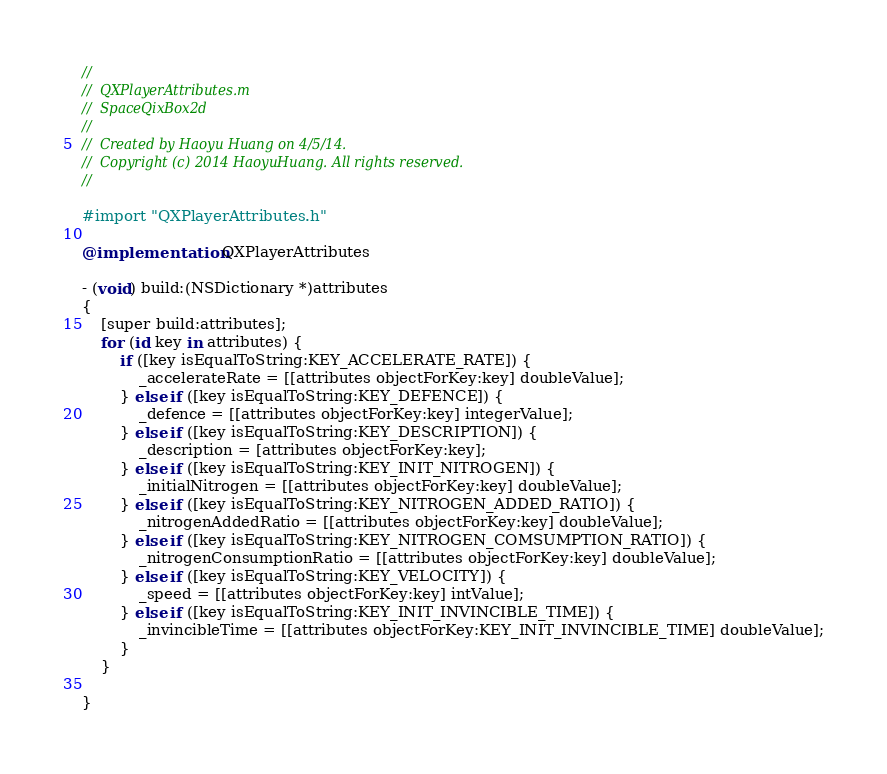Convert code to text. <code><loc_0><loc_0><loc_500><loc_500><_ObjectiveC_>//
//  QXPlayerAttributes.m
//  SpaceQixBox2d
//
//  Created by Haoyu Huang on 4/5/14.
//  Copyright (c) 2014 HaoyuHuang. All rights reserved.
//

#import "QXPlayerAttributes.h"

@implementation QXPlayerAttributes

- (void) build:(NSDictionary *)attributes
{
    [super build:attributes];
    for (id key in attributes) {
        if ([key isEqualToString:KEY_ACCELERATE_RATE]) {
            _accelerateRate = [[attributes objectForKey:key] doubleValue];
        } else if ([key isEqualToString:KEY_DEFENCE]) {
            _defence = [[attributes objectForKey:key] integerValue];
        } else if ([key isEqualToString:KEY_DESCRIPTION]) {
            _description = [attributes objectForKey:key];
        } else if ([key isEqualToString:KEY_INIT_NITROGEN]) {
            _initialNitrogen = [[attributes objectForKey:key] doubleValue];
        } else if ([key isEqualToString:KEY_NITROGEN_ADDED_RATIO]) {
            _nitrogenAddedRatio = [[attributes objectForKey:key] doubleValue];
        } else if ([key isEqualToString:KEY_NITROGEN_COMSUMPTION_RATIO]) {
            _nitrogenConsumptionRatio = [[attributes objectForKey:key] doubleValue];
        } else if ([key isEqualToString:KEY_VELOCITY]) {
            _speed = [[attributes objectForKey:key] intValue];
        } else if ([key isEqualToString:KEY_INIT_INVINCIBLE_TIME]) {
            _invincibleTime = [[attributes objectForKey:KEY_INIT_INVINCIBLE_TIME] doubleValue];
        }
    }
    
}
</code> 